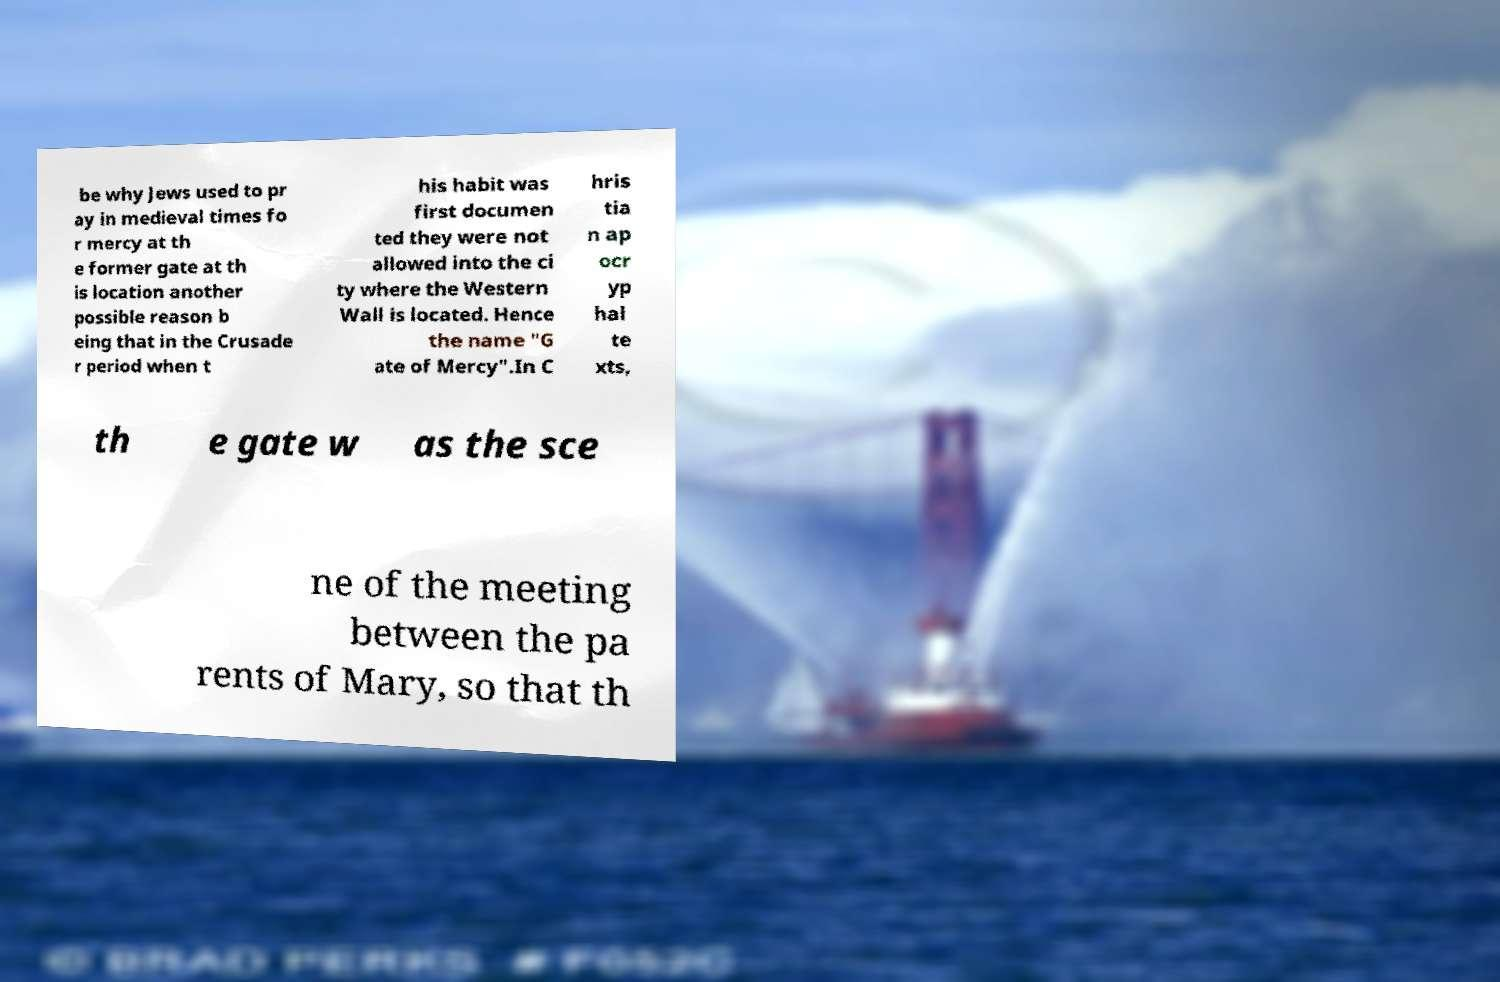Please read and relay the text visible in this image. What does it say? be why Jews used to pr ay in medieval times fo r mercy at th e former gate at th is location another possible reason b eing that in the Crusade r period when t his habit was first documen ted they were not allowed into the ci ty where the Western Wall is located. Hence the name "G ate of Mercy".In C hris tia n ap ocr yp hal te xts, th e gate w as the sce ne of the meeting between the pa rents of Mary, so that th 